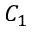Convert formula to latex. <formula><loc_0><loc_0><loc_500><loc_500>C _ { 1 }</formula> 